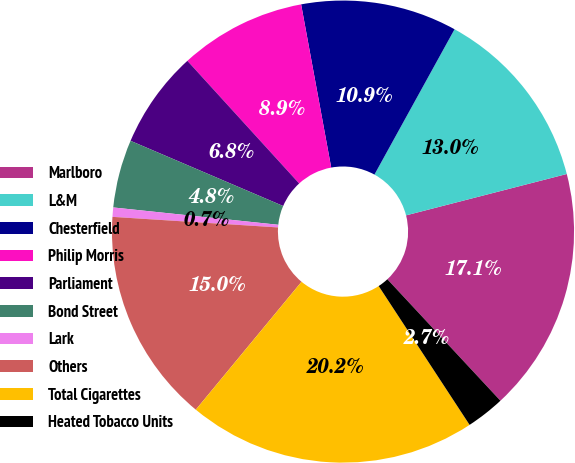Convert chart. <chart><loc_0><loc_0><loc_500><loc_500><pie_chart><fcel>Marlboro<fcel>L&M<fcel>Chesterfield<fcel>Philip Morris<fcel>Parliament<fcel>Bond Street<fcel>Lark<fcel>Others<fcel>Total Cigarettes<fcel>Heated Tobacco Units<nl><fcel>17.08%<fcel>12.97%<fcel>10.92%<fcel>8.86%<fcel>6.81%<fcel>4.76%<fcel>0.65%<fcel>15.02%<fcel>20.22%<fcel>2.7%<nl></chart> 